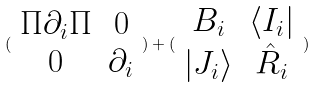<formula> <loc_0><loc_0><loc_500><loc_500>( \begin{array} { c c } \Pi \partial _ { i } \Pi & 0 \\ 0 & \partial _ { i } \end{array} ) + ( \begin{array} { c c } B _ { i } & \langle I _ { i } | \\ | J _ { i } \rangle & \hat { R } _ { i } \end{array} )</formula> 